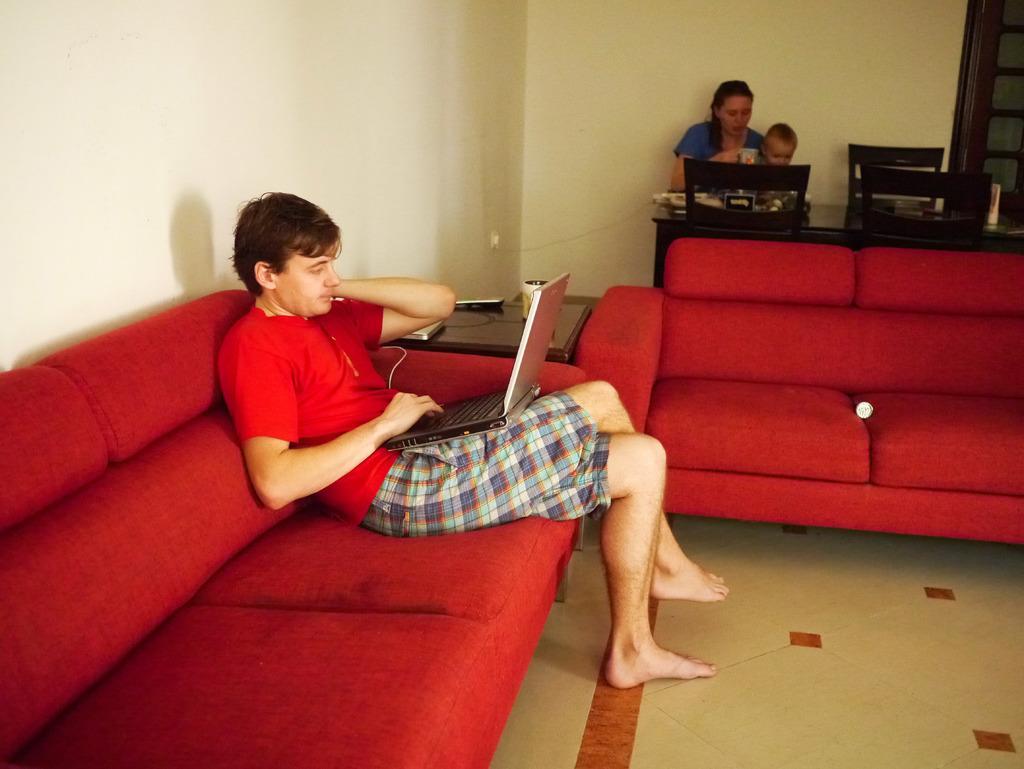In one or two sentences, can you explain what this image depicts? This picture is of inside. In the center there is a red color sofa, behind that there is a woman with a baby sitting on the chair and there is a table in front of her. On the left there is a man wearing a red color t-shirt and sitting on a red sofa and there is a table behind the sofa. In the background there is a wall and a window. 